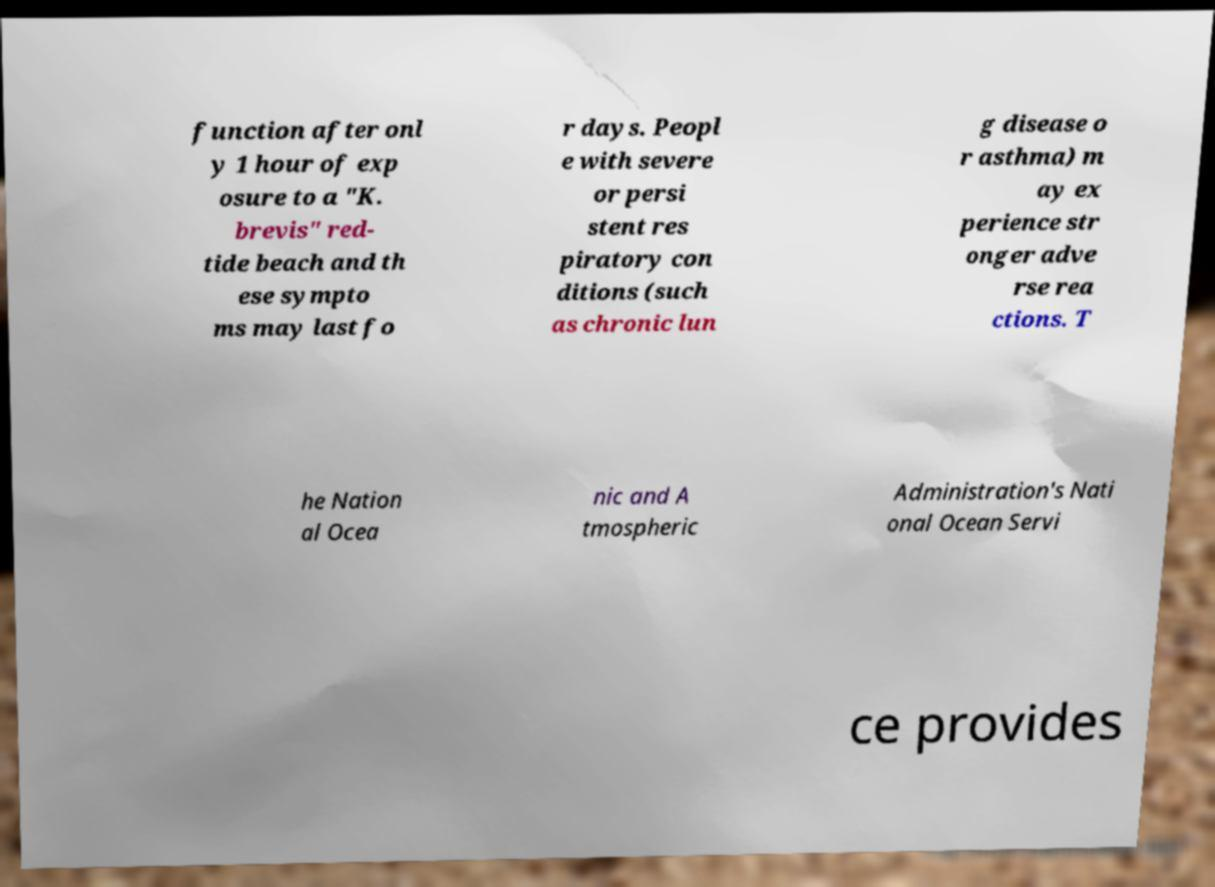Can you accurately transcribe the text from the provided image for me? function after onl y 1 hour of exp osure to a "K. brevis" red- tide beach and th ese sympto ms may last fo r days. Peopl e with severe or persi stent res piratory con ditions (such as chronic lun g disease o r asthma) m ay ex perience str onger adve rse rea ctions. T he Nation al Ocea nic and A tmospheric Administration's Nati onal Ocean Servi ce provides 